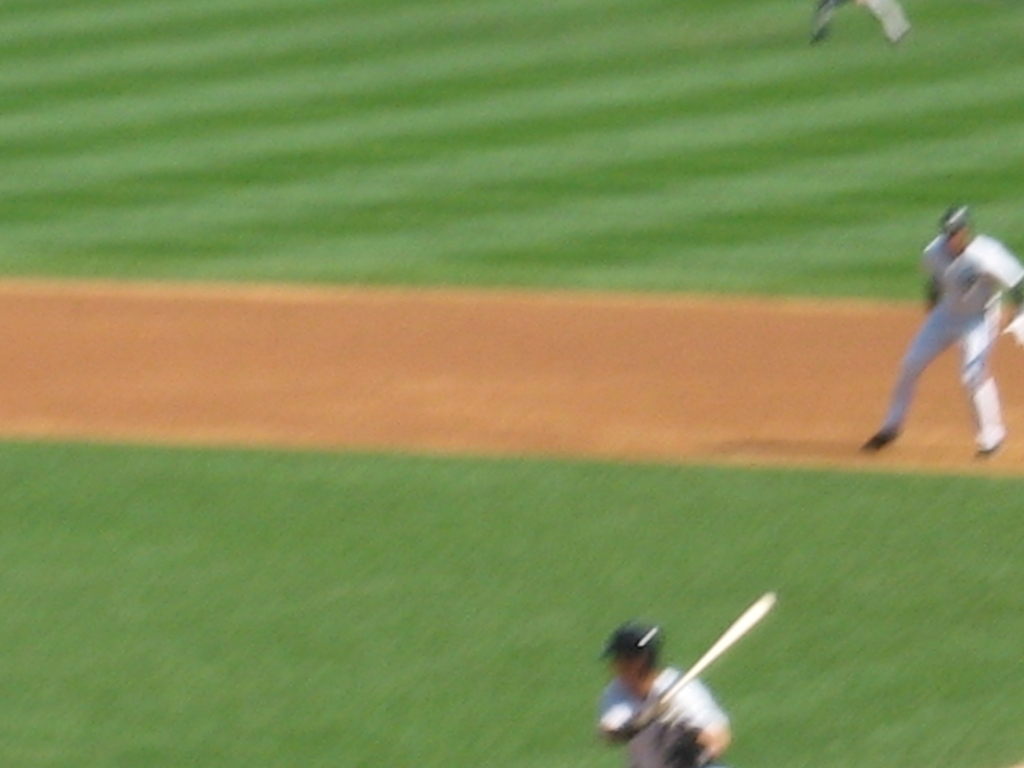Why is the image so blurry, and how could that have been prevented? The image is blurry due to motion blur and possibly camera shake. To prevent this, the photographer could have used a faster shutter speed, a steadier hand or support like a tripod, and possibly a higher ISO setting for a quicker exposure. What does a faster shutter speed do to an image? A faster shutter speed captures images more quickly, which can freeze motion and reduce the blur in fast-moving subjects, resulting in a sharper image. 